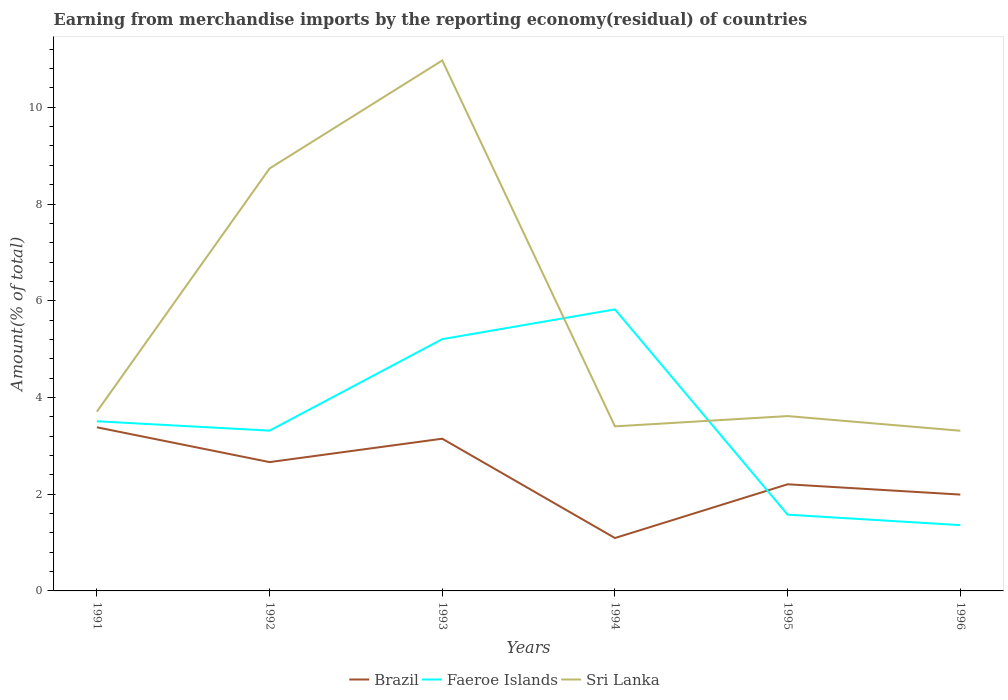How many different coloured lines are there?
Offer a terse response. 3. Across all years, what is the maximum percentage of amount earned from merchandise imports in Brazil?
Keep it short and to the point. 1.09. What is the total percentage of amount earned from merchandise imports in Sri Lanka in the graph?
Your answer should be compact. -0.21. What is the difference between the highest and the second highest percentage of amount earned from merchandise imports in Faeroe Islands?
Give a very brief answer. 4.46. Does the graph contain any zero values?
Offer a terse response. No. How many legend labels are there?
Your answer should be compact. 3. What is the title of the graph?
Your answer should be very brief. Earning from merchandise imports by the reporting economy(residual) of countries. Does "Sub-Saharan Africa (developing only)" appear as one of the legend labels in the graph?
Give a very brief answer. No. What is the label or title of the Y-axis?
Provide a short and direct response. Amount(% of total). What is the Amount(% of total) in Brazil in 1991?
Ensure brevity in your answer.  3.38. What is the Amount(% of total) of Faeroe Islands in 1991?
Provide a short and direct response. 3.51. What is the Amount(% of total) in Sri Lanka in 1991?
Your response must be concise. 3.71. What is the Amount(% of total) in Brazil in 1992?
Offer a very short reply. 2.66. What is the Amount(% of total) in Faeroe Islands in 1992?
Provide a short and direct response. 3.31. What is the Amount(% of total) in Sri Lanka in 1992?
Ensure brevity in your answer.  8.74. What is the Amount(% of total) in Brazil in 1993?
Offer a terse response. 3.15. What is the Amount(% of total) of Faeroe Islands in 1993?
Offer a terse response. 5.21. What is the Amount(% of total) in Sri Lanka in 1993?
Your response must be concise. 10.97. What is the Amount(% of total) in Brazil in 1994?
Your answer should be very brief. 1.09. What is the Amount(% of total) of Faeroe Islands in 1994?
Your response must be concise. 5.82. What is the Amount(% of total) of Sri Lanka in 1994?
Offer a terse response. 3.4. What is the Amount(% of total) of Brazil in 1995?
Keep it short and to the point. 2.21. What is the Amount(% of total) in Faeroe Islands in 1995?
Offer a very short reply. 1.58. What is the Amount(% of total) in Sri Lanka in 1995?
Offer a very short reply. 3.62. What is the Amount(% of total) in Brazil in 1996?
Give a very brief answer. 1.99. What is the Amount(% of total) of Faeroe Islands in 1996?
Give a very brief answer. 1.36. What is the Amount(% of total) of Sri Lanka in 1996?
Make the answer very short. 3.31. Across all years, what is the maximum Amount(% of total) of Brazil?
Your response must be concise. 3.38. Across all years, what is the maximum Amount(% of total) in Faeroe Islands?
Provide a succinct answer. 5.82. Across all years, what is the maximum Amount(% of total) of Sri Lanka?
Your answer should be compact. 10.97. Across all years, what is the minimum Amount(% of total) in Brazil?
Make the answer very short. 1.09. Across all years, what is the minimum Amount(% of total) in Faeroe Islands?
Ensure brevity in your answer.  1.36. Across all years, what is the minimum Amount(% of total) of Sri Lanka?
Your answer should be compact. 3.31. What is the total Amount(% of total) in Brazil in the graph?
Offer a very short reply. 14.49. What is the total Amount(% of total) in Faeroe Islands in the graph?
Your response must be concise. 20.79. What is the total Amount(% of total) in Sri Lanka in the graph?
Your response must be concise. 33.74. What is the difference between the Amount(% of total) of Brazil in 1991 and that in 1992?
Your response must be concise. 0.72. What is the difference between the Amount(% of total) of Faeroe Islands in 1991 and that in 1992?
Your answer should be compact. 0.19. What is the difference between the Amount(% of total) in Sri Lanka in 1991 and that in 1992?
Your response must be concise. -5.03. What is the difference between the Amount(% of total) in Brazil in 1991 and that in 1993?
Your answer should be compact. 0.24. What is the difference between the Amount(% of total) of Faeroe Islands in 1991 and that in 1993?
Give a very brief answer. -1.7. What is the difference between the Amount(% of total) in Sri Lanka in 1991 and that in 1993?
Your response must be concise. -7.26. What is the difference between the Amount(% of total) of Brazil in 1991 and that in 1994?
Ensure brevity in your answer.  2.29. What is the difference between the Amount(% of total) in Faeroe Islands in 1991 and that in 1994?
Make the answer very short. -2.31. What is the difference between the Amount(% of total) of Sri Lanka in 1991 and that in 1994?
Keep it short and to the point. 0.3. What is the difference between the Amount(% of total) in Brazil in 1991 and that in 1995?
Your response must be concise. 1.18. What is the difference between the Amount(% of total) of Faeroe Islands in 1991 and that in 1995?
Offer a terse response. 1.93. What is the difference between the Amount(% of total) in Sri Lanka in 1991 and that in 1995?
Give a very brief answer. 0.09. What is the difference between the Amount(% of total) of Brazil in 1991 and that in 1996?
Offer a terse response. 1.39. What is the difference between the Amount(% of total) of Faeroe Islands in 1991 and that in 1996?
Provide a short and direct response. 2.15. What is the difference between the Amount(% of total) of Sri Lanka in 1991 and that in 1996?
Your answer should be very brief. 0.39. What is the difference between the Amount(% of total) in Brazil in 1992 and that in 1993?
Keep it short and to the point. -0.48. What is the difference between the Amount(% of total) of Faeroe Islands in 1992 and that in 1993?
Offer a terse response. -1.89. What is the difference between the Amount(% of total) in Sri Lanka in 1992 and that in 1993?
Your answer should be compact. -2.23. What is the difference between the Amount(% of total) in Brazil in 1992 and that in 1994?
Your answer should be compact. 1.57. What is the difference between the Amount(% of total) in Faeroe Islands in 1992 and that in 1994?
Provide a short and direct response. -2.51. What is the difference between the Amount(% of total) in Sri Lanka in 1992 and that in 1994?
Give a very brief answer. 5.33. What is the difference between the Amount(% of total) of Brazil in 1992 and that in 1995?
Give a very brief answer. 0.46. What is the difference between the Amount(% of total) of Faeroe Islands in 1992 and that in 1995?
Make the answer very short. 1.74. What is the difference between the Amount(% of total) of Sri Lanka in 1992 and that in 1995?
Ensure brevity in your answer.  5.12. What is the difference between the Amount(% of total) in Brazil in 1992 and that in 1996?
Ensure brevity in your answer.  0.67. What is the difference between the Amount(% of total) in Faeroe Islands in 1992 and that in 1996?
Your answer should be very brief. 1.95. What is the difference between the Amount(% of total) in Sri Lanka in 1992 and that in 1996?
Offer a very short reply. 5.42. What is the difference between the Amount(% of total) in Brazil in 1993 and that in 1994?
Offer a very short reply. 2.05. What is the difference between the Amount(% of total) in Faeroe Islands in 1993 and that in 1994?
Offer a terse response. -0.62. What is the difference between the Amount(% of total) of Sri Lanka in 1993 and that in 1994?
Offer a very short reply. 7.57. What is the difference between the Amount(% of total) of Brazil in 1993 and that in 1995?
Keep it short and to the point. 0.94. What is the difference between the Amount(% of total) of Faeroe Islands in 1993 and that in 1995?
Make the answer very short. 3.63. What is the difference between the Amount(% of total) in Sri Lanka in 1993 and that in 1995?
Your answer should be compact. 7.35. What is the difference between the Amount(% of total) of Brazil in 1993 and that in 1996?
Your answer should be very brief. 1.16. What is the difference between the Amount(% of total) in Faeroe Islands in 1993 and that in 1996?
Your answer should be compact. 3.85. What is the difference between the Amount(% of total) in Sri Lanka in 1993 and that in 1996?
Your response must be concise. 7.66. What is the difference between the Amount(% of total) of Brazil in 1994 and that in 1995?
Your answer should be compact. -1.11. What is the difference between the Amount(% of total) in Faeroe Islands in 1994 and that in 1995?
Provide a short and direct response. 4.24. What is the difference between the Amount(% of total) of Sri Lanka in 1994 and that in 1995?
Ensure brevity in your answer.  -0.21. What is the difference between the Amount(% of total) in Brazil in 1994 and that in 1996?
Offer a very short reply. -0.9. What is the difference between the Amount(% of total) in Faeroe Islands in 1994 and that in 1996?
Your answer should be very brief. 4.46. What is the difference between the Amount(% of total) in Sri Lanka in 1994 and that in 1996?
Provide a succinct answer. 0.09. What is the difference between the Amount(% of total) in Brazil in 1995 and that in 1996?
Your answer should be compact. 0.21. What is the difference between the Amount(% of total) of Faeroe Islands in 1995 and that in 1996?
Provide a succinct answer. 0.22. What is the difference between the Amount(% of total) in Sri Lanka in 1995 and that in 1996?
Provide a short and direct response. 0.3. What is the difference between the Amount(% of total) of Brazil in 1991 and the Amount(% of total) of Faeroe Islands in 1992?
Provide a succinct answer. 0.07. What is the difference between the Amount(% of total) in Brazil in 1991 and the Amount(% of total) in Sri Lanka in 1992?
Your answer should be compact. -5.35. What is the difference between the Amount(% of total) of Faeroe Islands in 1991 and the Amount(% of total) of Sri Lanka in 1992?
Ensure brevity in your answer.  -5.23. What is the difference between the Amount(% of total) of Brazil in 1991 and the Amount(% of total) of Faeroe Islands in 1993?
Give a very brief answer. -1.82. What is the difference between the Amount(% of total) of Brazil in 1991 and the Amount(% of total) of Sri Lanka in 1993?
Offer a terse response. -7.59. What is the difference between the Amount(% of total) of Faeroe Islands in 1991 and the Amount(% of total) of Sri Lanka in 1993?
Your answer should be very brief. -7.46. What is the difference between the Amount(% of total) in Brazil in 1991 and the Amount(% of total) in Faeroe Islands in 1994?
Provide a short and direct response. -2.44. What is the difference between the Amount(% of total) of Brazil in 1991 and the Amount(% of total) of Sri Lanka in 1994?
Provide a succinct answer. -0.02. What is the difference between the Amount(% of total) of Faeroe Islands in 1991 and the Amount(% of total) of Sri Lanka in 1994?
Offer a terse response. 0.11. What is the difference between the Amount(% of total) in Brazil in 1991 and the Amount(% of total) in Faeroe Islands in 1995?
Provide a short and direct response. 1.81. What is the difference between the Amount(% of total) in Brazil in 1991 and the Amount(% of total) in Sri Lanka in 1995?
Keep it short and to the point. -0.23. What is the difference between the Amount(% of total) in Faeroe Islands in 1991 and the Amount(% of total) in Sri Lanka in 1995?
Offer a terse response. -0.11. What is the difference between the Amount(% of total) in Brazil in 1991 and the Amount(% of total) in Faeroe Islands in 1996?
Keep it short and to the point. 2.02. What is the difference between the Amount(% of total) of Brazil in 1991 and the Amount(% of total) of Sri Lanka in 1996?
Offer a very short reply. 0.07. What is the difference between the Amount(% of total) in Faeroe Islands in 1991 and the Amount(% of total) in Sri Lanka in 1996?
Provide a short and direct response. 0.2. What is the difference between the Amount(% of total) of Brazil in 1992 and the Amount(% of total) of Faeroe Islands in 1993?
Your answer should be very brief. -2.54. What is the difference between the Amount(% of total) in Brazil in 1992 and the Amount(% of total) in Sri Lanka in 1993?
Your answer should be compact. -8.3. What is the difference between the Amount(% of total) in Faeroe Islands in 1992 and the Amount(% of total) in Sri Lanka in 1993?
Make the answer very short. -7.65. What is the difference between the Amount(% of total) of Brazil in 1992 and the Amount(% of total) of Faeroe Islands in 1994?
Keep it short and to the point. -3.16. What is the difference between the Amount(% of total) of Brazil in 1992 and the Amount(% of total) of Sri Lanka in 1994?
Your answer should be compact. -0.74. What is the difference between the Amount(% of total) in Faeroe Islands in 1992 and the Amount(% of total) in Sri Lanka in 1994?
Ensure brevity in your answer.  -0.09. What is the difference between the Amount(% of total) of Brazil in 1992 and the Amount(% of total) of Faeroe Islands in 1995?
Make the answer very short. 1.09. What is the difference between the Amount(% of total) in Brazil in 1992 and the Amount(% of total) in Sri Lanka in 1995?
Make the answer very short. -0.95. What is the difference between the Amount(% of total) in Faeroe Islands in 1992 and the Amount(% of total) in Sri Lanka in 1995?
Give a very brief answer. -0.3. What is the difference between the Amount(% of total) of Brazil in 1992 and the Amount(% of total) of Faeroe Islands in 1996?
Provide a succinct answer. 1.3. What is the difference between the Amount(% of total) in Brazil in 1992 and the Amount(% of total) in Sri Lanka in 1996?
Give a very brief answer. -0.65. What is the difference between the Amount(% of total) in Faeroe Islands in 1992 and the Amount(% of total) in Sri Lanka in 1996?
Your answer should be compact. 0. What is the difference between the Amount(% of total) in Brazil in 1993 and the Amount(% of total) in Faeroe Islands in 1994?
Keep it short and to the point. -2.67. What is the difference between the Amount(% of total) of Brazil in 1993 and the Amount(% of total) of Sri Lanka in 1994?
Your answer should be very brief. -0.26. What is the difference between the Amount(% of total) in Faeroe Islands in 1993 and the Amount(% of total) in Sri Lanka in 1994?
Ensure brevity in your answer.  1.8. What is the difference between the Amount(% of total) of Brazil in 1993 and the Amount(% of total) of Faeroe Islands in 1995?
Your answer should be very brief. 1.57. What is the difference between the Amount(% of total) in Brazil in 1993 and the Amount(% of total) in Sri Lanka in 1995?
Your answer should be compact. -0.47. What is the difference between the Amount(% of total) of Faeroe Islands in 1993 and the Amount(% of total) of Sri Lanka in 1995?
Provide a succinct answer. 1.59. What is the difference between the Amount(% of total) in Brazil in 1993 and the Amount(% of total) in Faeroe Islands in 1996?
Offer a very short reply. 1.79. What is the difference between the Amount(% of total) of Brazil in 1993 and the Amount(% of total) of Sri Lanka in 1996?
Your answer should be compact. -0.16. What is the difference between the Amount(% of total) in Faeroe Islands in 1993 and the Amount(% of total) in Sri Lanka in 1996?
Provide a short and direct response. 1.89. What is the difference between the Amount(% of total) of Brazil in 1994 and the Amount(% of total) of Faeroe Islands in 1995?
Your answer should be very brief. -0.48. What is the difference between the Amount(% of total) in Brazil in 1994 and the Amount(% of total) in Sri Lanka in 1995?
Keep it short and to the point. -2.52. What is the difference between the Amount(% of total) of Faeroe Islands in 1994 and the Amount(% of total) of Sri Lanka in 1995?
Your answer should be very brief. 2.21. What is the difference between the Amount(% of total) of Brazil in 1994 and the Amount(% of total) of Faeroe Islands in 1996?
Your answer should be compact. -0.27. What is the difference between the Amount(% of total) in Brazil in 1994 and the Amount(% of total) in Sri Lanka in 1996?
Your answer should be very brief. -2.22. What is the difference between the Amount(% of total) in Faeroe Islands in 1994 and the Amount(% of total) in Sri Lanka in 1996?
Your answer should be compact. 2.51. What is the difference between the Amount(% of total) in Brazil in 1995 and the Amount(% of total) in Faeroe Islands in 1996?
Keep it short and to the point. 0.84. What is the difference between the Amount(% of total) in Brazil in 1995 and the Amount(% of total) in Sri Lanka in 1996?
Your response must be concise. -1.11. What is the difference between the Amount(% of total) of Faeroe Islands in 1995 and the Amount(% of total) of Sri Lanka in 1996?
Your answer should be very brief. -1.74. What is the average Amount(% of total) in Brazil per year?
Give a very brief answer. 2.41. What is the average Amount(% of total) in Faeroe Islands per year?
Ensure brevity in your answer.  3.46. What is the average Amount(% of total) in Sri Lanka per year?
Your answer should be very brief. 5.62. In the year 1991, what is the difference between the Amount(% of total) in Brazil and Amount(% of total) in Faeroe Islands?
Offer a very short reply. -0.12. In the year 1991, what is the difference between the Amount(% of total) in Brazil and Amount(% of total) in Sri Lanka?
Ensure brevity in your answer.  -0.32. In the year 1991, what is the difference between the Amount(% of total) in Faeroe Islands and Amount(% of total) in Sri Lanka?
Offer a very short reply. -0.2. In the year 1992, what is the difference between the Amount(% of total) of Brazil and Amount(% of total) of Faeroe Islands?
Your response must be concise. -0.65. In the year 1992, what is the difference between the Amount(% of total) in Brazil and Amount(% of total) in Sri Lanka?
Provide a short and direct response. -6.07. In the year 1992, what is the difference between the Amount(% of total) of Faeroe Islands and Amount(% of total) of Sri Lanka?
Your answer should be compact. -5.42. In the year 1993, what is the difference between the Amount(% of total) in Brazil and Amount(% of total) in Faeroe Islands?
Provide a short and direct response. -2.06. In the year 1993, what is the difference between the Amount(% of total) in Brazil and Amount(% of total) in Sri Lanka?
Ensure brevity in your answer.  -7.82. In the year 1993, what is the difference between the Amount(% of total) of Faeroe Islands and Amount(% of total) of Sri Lanka?
Give a very brief answer. -5.76. In the year 1994, what is the difference between the Amount(% of total) of Brazil and Amount(% of total) of Faeroe Islands?
Your response must be concise. -4.73. In the year 1994, what is the difference between the Amount(% of total) in Brazil and Amount(% of total) in Sri Lanka?
Your response must be concise. -2.31. In the year 1994, what is the difference between the Amount(% of total) of Faeroe Islands and Amount(% of total) of Sri Lanka?
Provide a succinct answer. 2.42. In the year 1995, what is the difference between the Amount(% of total) in Brazil and Amount(% of total) in Faeroe Islands?
Provide a short and direct response. 0.63. In the year 1995, what is the difference between the Amount(% of total) in Brazil and Amount(% of total) in Sri Lanka?
Make the answer very short. -1.41. In the year 1995, what is the difference between the Amount(% of total) of Faeroe Islands and Amount(% of total) of Sri Lanka?
Your response must be concise. -2.04. In the year 1996, what is the difference between the Amount(% of total) of Brazil and Amount(% of total) of Faeroe Islands?
Offer a terse response. 0.63. In the year 1996, what is the difference between the Amount(% of total) of Brazil and Amount(% of total) of Sri Lanka?
Offer a very short reply. -1.32. In the year 1996, what is the difference between the Amount(% of total) of Faeroe Islands and Amount(% of total) of Sri Lanka?
Provide a succinct answer. -1.95. What is the ratio of the Amount(% of total) in Brazil in 1991 to that in 1992?
Provide a succinct answer. 1.27. What is the ratio of the Amount(% of total) of Faeroe Islands in 1991 to that in 1992?
Ensure brevity in your answer.  1.06. What is the ratio of the Amount(% of total) of Sri Lanka in 1991 to that in 1992?
Keep it short and to the point. 0.42. What is the ratio of the Amount(% of total) of Brazil in 1991 to that in 1993?
Offer a terse response. 1.07. What is the ratio of the Amount(% of total) in Faeroe Islands in 1991 to that in 1993?
Offer a very short reply. 0.67. What is the ratio of the Amount(% of total) in Sri Lanka in 1991 to that in 1993?
Your response must be concise. 0.34. What is the ratio of the Amount(% of total) in Brazil in 1991 to that in 1994?
Keep it short and to the point. 3.09. What is the ratio of the Amount(% of total) of Faeroe Islands in 1991 to that in 1994?
Your answer should be very brief. 0.6. What is the ratio of the Amount(% of total) in Sri Lanka in 1991 to that in 1994?
Offer a very short reply. 1.09. What is the ratio of the Amount(% of total) in Brazil in 1991 to that in 1995?
Ensure brevity in your answer.  1.53. What is the ratio of the Amount(% of total) in Faeroe Islands in 1991 to that in 1995?
Offer a very short reply. 2.23. What is the ratio of the Amount(% of total) in Sri Lanka in 1991 to that in 1995?
Give a very brief answer. 1.03. What is the ratio of the Amount(% of total) of Brazil in 1991 to that in 1996?
Your response must be concise. 1.7. What is the ratio of the Amount(% of total) in Faeroe Islands in 1991 to that in 1996?
Provide a short and direct response. 2.58. What is the ratio of the Amount(% of total) in Sri Lanka in 1991 to that in 1996?
Provide a short and direct response. 1.12. What is the ratio of the Amount(% of total) in Brazil in 1992 to that in 1993?
Offer a very short reply. 0.85. What is the ratio of the Amount(% of total) in Faeroe Islands in 1992 to that in 1993?
Ensure brevity in your answer.  0.64. What is the ratio of the Amount(% of total) of Sri Lanka in 1992 to that in 1993?
Your answer should be very brief. 0.8. What is the ratio of the Amount(% of total) in Brazil in 1992 to that in 1994?
Offer a very short reply. 2.44. What is the ratio of the Amount(% of total) in Faeroe Islands in 1992 to that in 1994?
Provide a short and direct response. 0.57. What is the ratio of the Amount(% of total) in Sri Lanka in 1992 to that in 1994?
Provide a succinct answer. 2.57. What is the ratio of the Amount(% of total) of Brazil in 1992 to that in 1995?
Make the answer very short. 1.21. What is the ratio of the Amount(% of total) in Faeroe Islands in 1992 to that in 1995?
Offer a terse response. 2.1. What is the ratio of the Amount(% of total) in Sri Lanka in 1992 to that in 1995?
Give a very brief answer. 2.42. What is the ratio of the Amount(% of total) in Brazil in 1992 to that in 1996?
Provide a short and direct response. 1.34. What is the ratio of the Amount(% of total) in Faeroe Islands in 1992 to that in 1996?
Your answer should be very brief. 2.44. What is the ratio of the Amount(% of total) in Sri Lanka in 1992 to that in 1996?
Your response must be concise. 2.64. What is the ratio of the Amount(% of total) in Brazil in 1993 to that in 1994?
Ensure brevity in your answer.  2.88. What is the ratio of the Amount(% of total) in Faeroe Islands in 1993 to that in 1994?
Offer a terse response. 0.89. What is the ratio of the Amount(% of total) of Sri Lanka in 1993 to that in 1994?
Make the answer very short. 3.22. What is the ratio of the Amount(% of total) in Brazil in 1993 to that in 1995?
Your answer should be compact. 1.43. What is the ratio of the Amount(% of total) in Faeroe Islands in 1993 to that in 1995?
Ensure brevity in your answer.  3.3. What is the ratio of the Amount(% of total) in Sri Lanka in 1993 to that in 1995?
Make the answer very short. 3.03. What is the ratio of the Amount(% of total) in Brazil in 1993 to that in 1996?
Give a very brief answer. 1.58. What is the ratio of the Amount(% of total) in Faeroe Islands in 1993 to that in 1996?
Keep it short and to the point. 3.83. What is the ratio of the Amount(% of total) of Sri Lanka in 1993 to that in 1996?
Ensure brevity in your answer.  3.31. What is the ratio of the Amount(% of total) of Brazil in 1994 to that in 1995?
Your answer should be compact. 0.5. What is the ratio of the Amount(% of total) of Faeroe Islands in 1994 to that in 1995?
Provide a short and direct response. 3.69. What is the ratio of the Amount(% of total) of Sri Lanka in 1994 to that in 1995?
Your answer should be very brief. 0.94. What is the ratio of the Amount(% of total) of Brazil in 1994 to that in 1996?
Give a very brief answer. 0.55. What is the ratio of the Amount(% of total) of Faeroe Islands in 1994 to that in 1996?
Your response must be concise. 4.28. What is the ratio of the Amount(% of total) of Sri Lanka in 1994 to that in 1996?
Ensure brevity in your answer.  1.03. What is the ratio of the Amount(% of total) of Brazil in 1995 to that in 1996?
Give a very brief answer. 1.11. What is the ratio of the Amount(% of total) of Faeroe Islands in 1995 to that in 1996?
Your answer should be compact. 1.16. What is the ratio of the Amount(% of total) of Sri Lanka in 1995 to that in 1996?
Your answer should be very brief. 1.09. What is the difference between the highest and the second highest Amount(% of total) in Brazil?
Provide a short and direct response. 0.24. What is the difference between the highest and the second highest Amount(% of total) of Faeroe Islands?
Provide a short and direct response. 0.62. What is the difference between the highest and the second highest Amount(% of total) of Sri Lanka?
Make the answer very short. 2.23. What is the difference between the highest and the lowest Amount(% of total) in Brazil?
Offer a very short reply. 2.29. What is the difference between the highest and the lowest Amount(% of total) in Faeroe Islands?
Provide a short and direct response. 4.46. What is the difference between the highest and the lowest Amount(% of total) in Sri Lanka?
Offer a terse response. 7.66. 